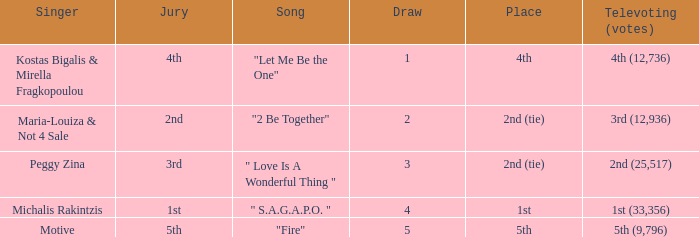What is the greatest draw that has 4th for place? 1.0. 